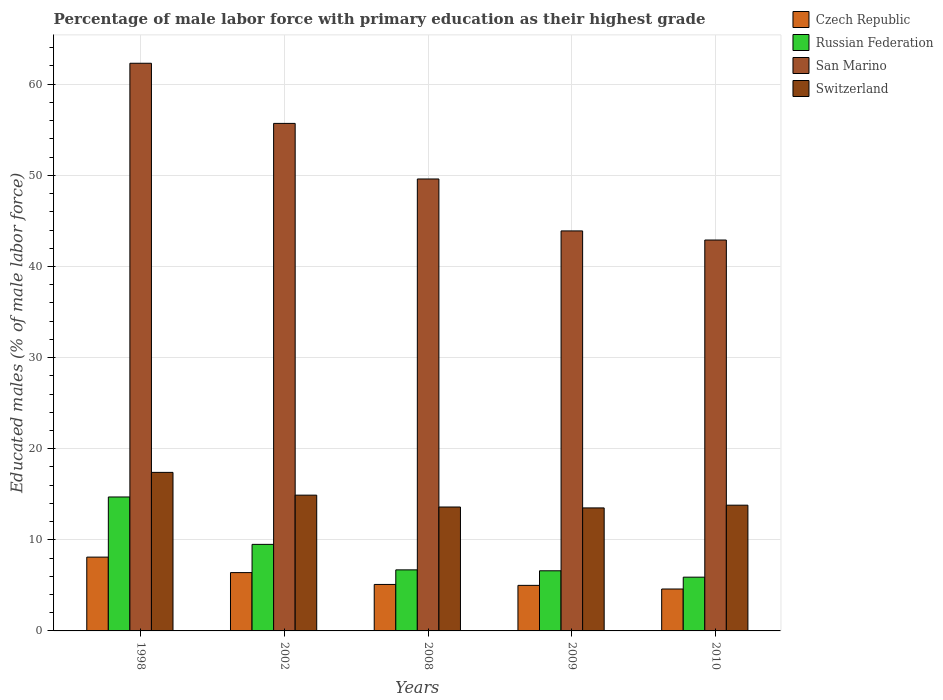How many different coloured bars are there?
Provide a succinct answer. 4. Are the number of bars on each tick of the X-axis equal?
Give a very brief answer. Yes. In how many cases, is the number of bars for a given year not equal to the number of legend labels?
Offer a terse response. 0. What is the percentage of male labor force with primary education in Switzerland in 2010?
Your response must be concise. 13.8. Across all years, what is the maximum percentage of male labor force with primary education in Switzerland?
Offer a terse response. 17.4. Across all years, what is the minimum percentage of male labor force with primary education in San Marino?
Make the answer very short. 42.9. What is the total percentage of male labor force with primary education in Switzerland in the graph?
Offer a very short reply. 73.2. What is the difference between the percentage of male labor force with primary education in San Marino in 2008 and that in 2010?
Make the answer very short. 6.7. What is the difference between the percentage of male labor force with primary education in Czech Republic in 2008 and the percentage of male labor force with primary education in Switzerland in 1998?
Offer a very short reply. -12.3. What is the average percentage of male labor force with primary education in Russian Federation per year?
Your response must be concise. 8.68. In the year 2002, what is the difference between the percentage of male labor force with primary education in Switzerland and percentage of male labor force with primary education in Russian Federation?
Your answer should be compact. 5.4. What is the ratio of the percentage of male labor force with primary education in Russian Federation in 2009 to that in 2010?
Offer a terse response. 1.12. Is the percentage of male labor force with primary education in San Marino in 2002 less than that in 2010?
Offer a very short reply. No. What is the difference between the highest and the second highest percentage of male labor force with primary education in Switzerland?
Offer a terse response. 2.5. What is the difference between the highest and the lowest percentage of male labor force with primary education in San Marino?
Your answer should be compact. 19.4. What does the 2nd bar from the left in 1998 represents?
Keep it short and to the point. Russian Federation. What does the 1st bar from the right in 2009 represents?
Ensure brevity in your answer.  Switzerland. How many years are there in the graph?
Offer a very short reply. 5. What is the difference between two consecutive major ticks on the Y-axis?
Your response must be concise. 10. Does the graph contain grids?
Your answer should be compact. Yes. How many legend labels are there?
Make the answer very short. 4. What is the title of the graph?
Provide a short and direct response. Percentage of male labor force with primary education as their highest grade. Does "Mauritius" appear as one of the legend labels in the graph?
Make the answer very short. No. What is the label or title of the X-axis?
Provide a short and direct response. Years. What is the label or title of the Y-axis?
Your answer should be compact. Educated males (% of male labor force). What is the Educated males (% of male labor force) in Czech Republic in 1998?
Keep it short and to the point. 8.1. What is the Educated males (% of male labor force) in Russian Federation in 1998?
Give a very brief answer. 14.7. What is the Educated males (% of male labor force) in San Marino in 1998?
Offer a terse response. 62.3. What is the Educated males (% of male labor force) of Switzerland in 1998?
Offer a very short reply. 17.4. What is the Educated males (% of male labor force) of Czech Republic in 2002?
Keep it short and to the point. 6.4. What is the Educated males (% of male labor force) in Russian Federation in 2002?
Offer a terse response. 9.5. What is the Educated males (% of male labor force) in San Marino in 2002?
Ensure brevity in your answer.  55.7. What is the Educated males (% of male labor force) in Switzerland in 2002?
Offer a very short reply. 14.9. What is the Educated males (% of male labor force) of Czech Republic in 2008?
Make the answer very short. 5.1. What is the Educated males (% of male labor force) of Russian Federation in 2008?
Provide a succinct answer. 6.7. What is the Educated males (% of male labor force) of San Marino in 2008?
Keep it short and to the point. 49.6. What is the Educated males (% of male labor force) in Switzerland in 2008?
Ensure brevity in your answer.  13.6. What is the Educated males (% of male labor force) of Russian Federation in 2009?
Make the answer very short. 6.6. What is the Educated males (% of male labor force) in San Marino in 2009?
Provide a succinct answer. 43.9. What is the Educated males (% of male labor force) in Switzerland in 2009?
Your response must be concise. 13.5. What is the Educated males (% of male labor force) in Czech Republic in 2010?
Provide a succinct answer. 4.6. What is the Educated males (% of male labor force) in Russian Federation in 2010?
Keep it short and to the point. 5.9. What is the Educated males (% of male labor force) in San Marino in 2010?
Ensure brevity in your answer.  42.9. What is the Educated males (% of male labor force) of Switzerland in 2010?
Your answer should be very brief. 13.8. Across all years, what is the maximum Educated males (% of male labor force) of Czech Republic?
Offer a terse response. 8.1. Across all years, what is the maximum Educated males (% of male labor force) in Russian Federation?
Provide a succinct answer. 14.7. Across all years, what is the maximum Educated males (% of male labor force) of San Marino?
Keep it short and to the point. 62.3. Across all years, what is the maximum Educated males (% of male labor force) of Switzerland?
Your answer should be very brief. 17.4. Across all years, what is the minimum Educated males (% of male labor force) in Czech Republic?
Provide a succinct answer. 4.6. Across all years, what is the minimum Educated males (% of male labor force) in Russian Federation?
Give a very brief answer. 5.9. Across all years, what is the minimum Educated males (% of male labor force) of San Marino?
Your answer should be compact. 42.9. Across all years, what is the minimum Educated males (% of male labor force) of Switzerland?
Offer a very short reply. 13.5. What is the total Educated males (% of male labor force) in Czech Republic in the graph?
Your answer should be very brief. 29.2. What is the total Educated males (% of male labor force) of Russian Federation in the graph?
Make the answer very short. 43.4. What is the total Educated males (% of male labor force) of San Marino in the graph?
Give a very brief answer. 254.4. What is the total Educated males (% of male labor force) of Switzerland in the graph?
Your response must be concise. 73.2. What is the difference between the Educated males (% of male labor force) in Russian Federation in 1998 and that in 2002?
Provide a short and direct response. 5.2. What is the difference between the Educated males (% of male labor force) of Czech Republic in 1998 and that in 2008?
Offer a very short reply. 3. What is the difference between the Educated males (% of male labor force) of San Marino in 1998 and that in 2008?
Provide a short and direct response. 12.7. What is the difference between the Educated males (% of male labor force) of Russian Federation in 1998 and that in 2009?
Your answer should be very brief. 8.1. What is the difference between the Educated males (% of male labor force) of San Marino in 1998 and that in 2009?
Offer a terse response. 18.4. What is the difference between the Educated males (% of male labor force) in Czech Republic in 1998 and that in 2010?
Ensure brevity in your answer.  3.5. What is the difference between the Educated males (% of male labor force) of Czech Republic in 2002 and that in 2008?
Offer a terse response. 1.3. What is the difference between the Educated males (% of male labor force) in San Marino in 2002 and that in 2008?
Provide a short and direct response. 6.1. What is the difference between the Educated males (% of male labor force) in Switzerland in 2002 and that in 2008?
Provide a short and direct response. 1.3. What is the difference between the Educated males (% of male labor force) of Czech Republic in 2002 and that in 2010?
Ensure brevity in your answer.  1.8. What is the difference between the Educated males (% of male labor force) in Russian Federation in 2002 and that in 2010?
Make the answer very short. 3.6. What is the difference between the Educated males (% of male labor force) of Switzerland in 2002 and that in 2010?
Make the answer very short. 1.1. What is the difference between the Educated males (% of male labor force) in Czech Republic in 2008 and that in 2009?
Provide a short and direct response. 0.1. What is the difference between the Educated males (% of male labor force) in Russian Federation in 2008 and that in 2009?
Offer a terse response. 0.1. What is the difference between the Educated males (% of male labor force) of San Marino in 2008 and that in 2009?
Provide a short and direct response. 5.7. What is the difference between the Educated males (% of male labor force) in Czech Republic in 2009 and that in 2010?
Make the answer very short. 0.4. What is the difference between the Educated males (% of male labor force) of Russian Federation in 2009 and that in 2010?
Provide a short and direct response. 0.7. What is the difference between the Educated males (% of male labor force) in Switzerland in 2009 and that in 2010?
Provide a short and direct response. -0.3. What is the difference between the Educated males (% of male labor force) of Czech Republic in 1998 and the Educated males (% of male labor force) of San Marino in 2002?
Offer a terse response. -47.6. What is the difference between the Educated males (% of male labor force) of Czech Republic in 1998 and the Educated males (% of male labor force) of Switzerland in 2002?
Ensure brevity in your answer.  -6.8. What is the difference between the Educated males (% of male labor force) in Russian Federation in 1998 and the Educated males (% of male labor force) in San Marino in 2002?
Your answer should be compact. -41. What is the difference between the Educated males (% of male labor force) of San Marino in 1998 and the Educated males (% of male labor force) of Switzerland in 2002?
Make the answer very short. 47.4. What is the difference between the Educated males (% of male labor force) of Czech Republic in 1998 and the Educated males (% of male labor force) of San Marino in 2008?
Your answer should be compact. -41.5. What is the difference between the Educated males (% of male labor force) of Czech Republic in 1998 and the Educated males (% of male labor force) of Switzerland in 2008?
Make the answer very short. -5.5. What is the difference between the Educated males (% of male labor force) in Russian Federation in 1998 and the Educated males (% of male labor force) in San Marino in 2008?
Provide a succinct answer. -34.9. What is the difference between the Educated males (% of male labor force) of San Marino in 1998 and the Educated males (% of male labor force) of Switzerland in 2008?
Keep it short and to the point. 48.7. What is the difference between the Educated males (% of male labor force) in Czech Republic in 1998 and the Educated males (% of male labor force) in Russian Federation in 2009?
Your answer should be compact. 1.5. What is the difference between the Educated males (% of male labor force) of Czech Republic in 1998 and the Educated males (% of male labor force) of San Marino in 2009?
Ensure brevity in your answer.  -35.8. What is the difference between the Educated males (% of male labor force) of Czech Republic in 1998 and the Educated males (% of male labor force) of Switzerland in 2009?
Your answer should be compact. -5.4. What is the difference between the Educated males (% of male labor force) of Russian Federation in 1998 and the Educated males (% of male labor force) of San Marino in 2009?
Give a very brief answer. -29.2. What is the difference between the Educated males (% of male labor force) of San Marino in 1998 and the Educated males (% of male labor force) of Switzerland in 2009?
Make the answer very short. 48.8. What is the difference between the Educated males (% of male labor force) in Czech Republic in 1998 and the Educated males (% of male labor force) in San Marino in 2010?
Your answer should be compact. -34.8. What is the difference between the Educated males (% of male labor force) of Czech Republic in 1998 and the Educated males (% of male labor force) of Switzerland in 2010?
Give a very brief answer. -5.7. What is the difference between the Educated males (% of male labor force) in Russian Federation in 1998 and the Educated males (% of male labor force) in San Marino in 2010?
Keep it short and to the point. -28.2. What is the difference between the Educated males (% of male labor force) in San Marino in 1998 and the Educated males (% of male labor force) in Switzerland in 2010?
Your response must be concise. 48.5. What is the difference between the Educated males (% of male labor force) of Czech Republic in 2002 and the Educated males (% of male labor force) of Russian Federation in 2008?
Give a very brief answer. -0.3. What is the difference between the Educated males (% of male labor force) of Czech Republic in 2002 and the Educated males (% of male labor force) of San Marino in 2008?
Give a very brief answer. -43.2. What is the difference between the Educated males (% of male labor force) in Russian Federation in 2002 and the Educated males (% of male labor force) in San Marino in 2008?
Provide a short and direct response. -40.1. What is the difference between the Educated males (% of male labor force) of Russian Federation in 2002 and the Educated males (% of male labor force) of Switzerland in 2008?
Offer a very short reply. -4.1. What is the difference between the Educated males (% of male labor force) of San Marino in 2002 and the Educated males (% of male labor force) of Switzerland in 2008?
Your answer should be compact. 42.1. What is the difference between the Educated males (% of male labor force) of Czech Republic in 2002 and the Educated males (% of male labor force) of Russian Federation in 2009?
Provide a short and direct response. -0.2. What is the difference between the Educated males (% of male labor force) of Czech Republic in 2002 and the Educated males (% of male labor force) of San Marino in 2009?
Your answer should be very brief. -37.5. What is the difference between the Educated males (% of male labor force) of Russian Federation in 2002 and the Educated males (% of male labor force) of San Marino in 2009?
Your answer should be compact. -34.4. What is the difference between the Educated males (% of male labor force) in Russian Federation in 2002 and the Educated males (% of male labor force) in Switzerland in 2009?
Offer a very short reply. -4. What is the difference between the Educated males (% of male labor force) in San Marino in 2002 and the Educated males (% of male labor force) in Switzerland in 2009?
Provide a succinct answer. 42.2. What is the difference between the Educated males (% of male labor force) of Czech Republic in 2002 and the Educated males (% of male labor force) of Russian Federation in 2010?
Give a very brief answer. 0.5. What is the difference between the Educated males (% of male labor force) in Czech Republic in 2002 and the Educated males (% of male labor force) in San Marino in 2010?
Offer a terse response. -36.5. What is the difference between the Educated males (% of male labor force) of Czech Republic in 2002 and the Educated males (% of male labor force) of Switzerland in 2010?
Give a very brief answer. -7.4. What is the difference between the Educated males (% of male labor force) in Russian Federation in 2002 and the Educated males (% of male labor force) in San Marino in 2010?
Your answer should be compact. -33.4. What is the difference between the Educated males (% of male labor force) of Russian Federation in 2002 and the Educated males (% of male labor force) of Switzerland in 2010?
Provide a short and direct response. -4.3. What is the difference between the Educated males (% of male labor force) of San Marino in 2002 and the Educated males (% of male labor force) of Switzerland in 2010?
Your answer should be compact. 41.9. What is the difference between the Educated males (% of male labor force) in Czech Republic in 2008 and the Educated males (% of male labor force) in Russian Federation in 2009?
Offer a very short reply. -1.5. What is the difference between the Educated males (% of male labor force) of Czech Republic in 2008 and the Educated males (% of male labor force) of San Marino in 2009?
Offer a terse response. -38.8. What is the difference between the Educated males (% of male labor force) of Czech Republic in 2008 and the Educated males (% of male labor force) of Switzerland in 2009?
Your answer should be very brief. -8.4. What is the difference between the Educated males (% of male labor force) in Russian Federation in 2008 and the Educated males (% of male labor force) in San Marino in 2009?
Your answer should be compact. -37.2. What is the difference between the Educated males (% of male labor force) in San Marino in 2008 and the Educated males (% of male labor force) in Switzerland in 2009?
Provide a short and direct response. 36.1. What is the difference between the Educated males (% of male labor force) in Czech Republic in 2008 and the Educated males (% of male labor force) in Russian Federation in 2010?
Provide a short and direct response. -0.8. What is the difference between the Educated males (% of male labor force) of Czech Republic in 2008 and the Educated males (% of male labor force) of San Marino in 2010?
Make the answer very short. -37.8. What is the difference between the Educated males (% of male labor force) in Russian Federation in 2008 and the Educated males (% of male labor force) in San Marino in 2010?
Give a very brief answer. -36.2. What is the difference between the Educated males (% of male labor force) in San Marino in 2008 and the Educated males (% of male labor force) in Switzerland in 2010?
Give a very brief answer. 35.8. What is the difference between the Educated males (% of male labor force) of Czech Republic in 2009 and the Educated males (% of male labor force) of Russian Federation in 2010?
Your answer should be compact. -0.9. What is the difference between the Educated males (% of male labor force) of Czech Republic in 2009 and the Educated males (% of male labor force) of San Marino in 2010?
Provide a succinct answer. -37.9. What is the difference between the Educated males (% of male labor force) in Russian Federation in 2009 and the Educated males (% of male labor force) in San Marino in 2010?
Provide a short and direct response. -36.3. What is the difference between the Educated males (% of male labor force) of San Marino in 2009 and the Educated males (% of male labor force) of Switzerland in 2010?
Your response must be concise. 30.1. What is the average Educated males (% of male labor force) in Czech Republic per year?
Provide a succinct answer. 5.84. What is the average Educated males (% of male labor force) of Russian Federation per year?
Keep it short and to the point. 8.68. What is the average Educated males (% of male labor force) in San Marino per year?
Keep it short and to the point. 50.88. What is the average Educated males (% of male labor force) of Switzerland per year?
Provide a succinct answer. 14.64. In the year 1998, what is the difference between the Educated males (% of male labor force) in Czech Republic and Educated males (% of male labor force) in San Marino?
Give a very brief answer. -54.2. In the year 1998, what is the difference between the Educated males (% of male labor force) of Czech Republic and Educated males (% of male labor force) of Switzerland?
Your response must be concise. -9.3. In the year 1998, what is the difference between the Educated males (% of male labor force) of Russian Federation and Educated males (% of male labor force) of San Marino?
Make the answer very short. -47.6. In the year 1998, what is the difference between the Educated males (% of male labor force) in San Marino and Educated males (% of male labor force) in Switzerland?
Provide a succinct answer. 44.9. In the year 2002, what is the difference between the Educated males (% of male labor force) of Czech Republic and Educated males (% of male labor force) of Russian Federation?
Make the answer very short. -3.1. In the year 2002, what is the difference between the Educated males (% of male labor force) of Czech Republic and Educated males (% of male labor force) of San Marino?
Make the answer very short. -49.3. In the year 2002, what is the difference between the Educated males (% of male labor force) of Russian Federation and Educated males (% of male labor force) of San Marino?
Provide a succinct answer. -46.2. In the year 2002, what is the difference between the Educated males (% of male labor force) of San Marino and Educated males (% of male labor force) of Switzerland?
Your answer should be very brief. 40.8. In the year 2008, what is the difference between the Educated males (% of male labor force) of Czech Republic and Educated males (% of male labor force) of San Marino?
Your answer should be compact. -44.5. In the year 2008, what is the difference between the Educated males (% of male labor force) in Russian Federation and Educated males (% of male labor force) in San Marino?
Keep it short and to the point. -42.9. In the year 2008, what is the difference between the Educated males (% of male labor force) in Russian Federation and Educated males (% of male labor force) in Switzerland?
Your response must be concise. -6.9. In the year 2008, what is the difference between the Educated males (% of male labor force) in San Marino and Educated males (% of male labor force) in Switzerland?
Your answer should be compact. 36. In the year 2009, what is the difference between the Educated males (% of male labor force) in Czech Republic and Educated males (% of male labor force) in San Marino?
Make the answer very short. -38.9. In the year 2009, what is the difference between the Educated males (% of male labor force) of Czech Republic and Educated males (% of male labor force) of Switzerland?
Provide a short and direct response. -8.5. In the year 2009, what is the difference between the Educated males (% of male labor force) in Russian Federation and Educated males (% of male labor force) in San Marino?
Keep it short and to the point. -37.3. In the year 2009, what is the difference between the Educated males (% of male labor force) in San Marino and Educated males (% of male labor force) in Switzerland?
Your answer should be very brief. 30.4. In the year 2010, what is the difference between the Educated males (% of male labor force) in Czech Republic and Educated males (% of male labor force) in San Marino?
Offer a terse response. -38.3. In the year 2010, what is the difference between the Educated males (% of male labor force) of Czech Republic and Educated males (% of male labor force) of Switzerland?
Provide a succinct answer. -9.2. In the year 2010, what is the difference between the Educated males (% of male labor force) of Russian Federation and Educated males (% of male labor force) of San Marino?
Provide a succinct answer. -37. In the year 2010, what is the difference between the Educated males (% of male labor force) in Russian Federation and Educated males (% of male labor force) in Switzerland?
Ensure brevity in your answer.  -7.9. In the year 2010, what is the difference between the Educated males (% of male labor force) of San Marino and Educated males (% of male labor force) of Switzerland?
Give a very brief answer. 29.1. What is the ratio of the Educated males (% of male labor force) of Czech Republic in 1998 to that in 2002?
Your answer should be compact. 1.27. What is the ratio of the Educated males (% of male labor force) in Russian Federation in 1998 to that in 2002?
Offer a terse response. 1.55. What is the ratio of the Educated males (% of male labor force) of San Marino in 1998 to that in 2002?
Provide a succinct answer. 1.12. What is the ratio of the Educated males (% of male labor force) of Switzerland in 1998 to that in 2002?
Give a very brief answer. 1.17. What is the ratio of the Educated males (% of male labor force) in Czech Republic in 1998 to that in 2008?
Offer a terse response. 1.59. What is the ratio of the Educated males (% of male labor force) in Russian Federation in 1998 to that in 2008?
Your answer should be very brief. 2.19. What is the ratio of the Educated males (% of male labor force) of San Marino in 1998 to that in 2008?
Your answer should be compact. 1.26. What is the ratio of the Educated males (% of male labor force) of Switzerland in 1998 to that in 2008?
Your response must be concise. 1.28. What is the ratio of the Educated males (% of male labor force) of Czech Republic in 1998 to that in 2009?
Your response must be concise. 1.62. What is the ratio of the Educated males (% of male labor force) of Russian Federation in 1998 to that in 2009?
Provide a succinct answer. 2.23. What is the ratio of the Educated males (% of male labor force) in San Marino in 1998 to that in 2009?
Make the answer very short. 1.42. What is the ratio of the Educated males (% of male labor force) of Switzerland in 1998 to that in 2009?
Ensure brevity in your answer.  1.29. What is the ratio of the Educated males (% of male labor force) in Czech Republic in 1998 to that in 2010?
Your answer should be compact. 1.76. What is the ratio of the Educated males (% of male labor force) of Russian Federation in 1998 to that in 2010?
Offer a very short reply. 2.49. What is the ratio of the Educated males (% of male labor force) in San Marino in 1998 to that in 2010?
Offer a terse response. 1.45. What is the ratio of the Educated males (% of male labor force) in Switzerland in 1998 to that in 2010?
Keep it short and to the point. 1.26. What is the ratio of the Educated males (% of male labor force) in Czech Republic in 2002 to that in 2008?
Your response must be concise. 1.25. What is the ratio of the Educated males (% of male labor force) in Russian Federation in 2002 to that in 2008?
Your answer should be very brief. 1.42. What is the ratio of the Educated males (% of male labor force) of San Marino in 2002 to that in 2008?
Offer a very short reply. 1.12. What is the ratio of the Educated males (% of male labor force) in Switzerland in 2002 to that in 2008?
Make the answer very short. 1.1. What is the ratio of the Educated males (% of male labor force) of Czech Republic in 2002 to that in 2009?
Ensure brevity in your answer.  1.28. What is the ratio of the Educated males (% of male labor force) in Russian Federation in 2002 to that in 2009?
Provide a short and direct response. 1.44. What is the ratio of the Educated males (% of male labor force) in San Marino in 2002 to that in 2009?
Your answer should be very brief. 1.27. What is the ratio of the Educated males (% of male labor force) of Switzerland in 2002 to that in 2009?
Offer a terse response. 1.1. What is the ratio of the Educated males (% of male labor force) in Czech Republic in 2002 to that in 2010?
Offer a very short reply. 1.39. What is the ratio of the Educated males (% of male labor force) in Russian Federation in 2002 to that in 2010?
Make the answer very short. 1.61. What is the ratio of the Educated males (% of male labor force) of San Marino in 2002 to that in 2010?
Your response must be concise. 1.3. What is the ratio of the Educated males (% of male labor force) in Switzerland in 2002 to that in 2010?
Give a very brief answer. 1.08. What is the ratio of the Educated males (% of male labor force) of Russian Federation in 2008 to that in 2009?
Provide a succinct answer. 1.02. What is the ratio of the Educated males (% of male labor force) in San Marino in 2008 to that in 2009?
Your answer should be compact. 1.13. What is the ratio of the Educated males (% of male labor force) of Switzerland in 2008 to that in 2009?
Provide a succinct answer. 1.01. What is the ratio of the Educated males (% of male labor force) in Czech Republic in 2008 to that in 2010?
Offer a terse response. 1.11. What is the ratio of the Educated males (% of male labor force) of Russian Federation in 2008 to that in 2010?
Your answer should be compact. 1.14. What is the ratio of the Educated males (% of male labor force) of San Marino in 2008 to that in 2010?
Provide a short and direct response. 1.16. What is the ratio of the Educated males (% of male labor force) in Switzerland in 2008 to that in 2010?
Provide a short and direct response. 0.99. What is the ratio of the Educated males (% of male labor force) of Czech Republic in 2009 to that in 2010?
Make the answer very short. 1.09. What is the ratio of the Educated males (% of male labor force) in Russian Federation in 2009 to that in 2010?
Make the answer very short. 1.12. What is the ratio of the Educated males (% of male labor force) in San Marino in 2009 to that in 2010?
Your response must be concise. 1.02. What is the ratio of the Educated males (% of male labor force) in Switzerland in 2009 to that in 2010?
Provide a short and direct response. 0.98. What is the difference between the highest and the second highest Educated males (% of male labor force) in Russian Federation?
Offer a very short reply. 5.2. What is the difference between the highest and the second highest Educated males (% of male labor force) of San Marino?
Keep it short and to the point. 6.6. What is the difference between the highest and the second highest Educated males (% of male labor force) in Switzerland?
Give a very brief answer. 2.5. What is the difference between the highest and the lowest Educated males (% of male labor force) of Czech Republic?
Your answer should be very brief. 3.5. What is the difference between the highest and the lowest Educated males (% of male labor force) in Russian Federation?
Make the answer very short. 8.8. What is the difference between the highest and the lowest Educated males (% of male labor force) in San Marino?
Your answer should be compact. 19.4. What is the difference between the highest and the lowest Educated males (% of male labor force) in Switzerland?
Keep it short and to the point. 3.9. 